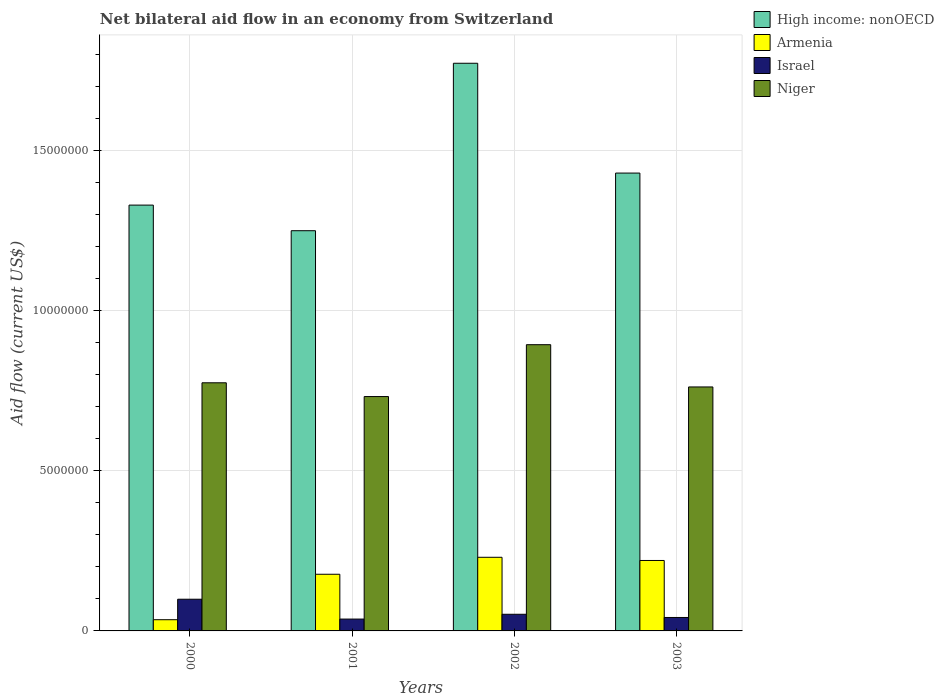How many groups of bars are there?
Offer a terse response. 4. Are the number of bars per tick equal to the number of legend labels?
Offer a terse response. Yes. Are the number of bars on each tick of the X-axis equal?
Give a very brief answer. Yes. What is the label of the 2nd group of bars from the left?
Give a very brief answer. 2001. In how many cases, is the number of bars for a given year not equal to the number of legend labels?
Offer a terse response. 0. What is the net bilateral aid flow in Armenia in 2002?
Give a very brief answer. 2.30e+06. Across all years, what is the maximum net bilateral aid flow in Armenia?
Provide a succinct answer. 2.30e+06. In which year was the net bilateral aid flow in Niger maximum?
Offer a terse response. 2002. What is the total net bilateral aid flow in Niger in the graph?
Your response must be concise. 3.16e+07. What is the difference between the net bilateral aid flow in High income: nonOECD in 2000 and that in 2002?
Make the answer very short. -4.43e+06. What is the difference between the net bilateral aid flow in Armenia in 2003 and the net bilateral aid flow in High income: nonOECD in 2001?
Your answer should be compact. -1.03e+07. What is the average net bilateral aid flow in Niger per year?
Ensure brevity in your answer.  7.91e+06. In the year 2002, what is the difference between the net bilateral aid flow in Israel and net bilateral aid flow in Niger?
Your answer should be very brief. -8.42e+06. What is the ratio of the net bilateral aid flow in Niger in 2001 to that in 2003?
Give a very brief answer. 0.96. What is the difference between the highest and the second highest net bilateral aid flow in High income: nonOECD?
Give a very brief answer. 3.43e+06. What is the difference between the highest and the lowest net bilateral aid flow in Niger?
Make the answer very short. 1.62e+06. In how many years, is the net bilateral aid flow in Israel greater than the average net bilateral aid flow in Israel taken over all years?
Your answer should be very brief. 1. Is the sum of the net bilateral aid flow in High income: nonOECD in 2001 and 2002 greater than the maximum net bilateral aid flow in Armenia across all years?
Your answer should be very brief. Yes. What does the 2nd bar from the left in 2001 represents?
Give a very brief answer. Armenia. What does the 4th bar from the right in 2002 represents?
Provide a succinct answer. High income: nonOECD. Is it the case that in every year, the sum of the net bilateral aid flow in Armenia and net bilateral aid flow in Israel is greater than the net bilateral aid flow in Niger?
Give a very brief answer. No. Are all the bars in the graph horizontal?
Offer a terse response. No. How many years are there in the graph?
Make the answer very short. 4. What is the difference between two consecutive major ticks on the Y-axis?
Your answer should be very brief. 5.00e+06. Does the graph contain grids?
Provide a succinct answer. Yes. How many legend labels are there?
Provide a short and direct response. 4. How are the legend labels stacked?
Ensure brevity in your answer.  Vertical. What is the title of the graph?
Your answer should be very brief. Net bilateral aid flow in an economy from Switzerland. Does "Kuwait" appear as one of the legend labels in the graph?
Offer a very short reply. No. What is the label or title of the X-axis?
Offer a very short reply. Years. What is the Aid flow (current US$) of High income: nonOECD in 2000?
Give a very brief answer. 1.33e+07. What is the Aid flow (current US$) of Armenia in 2000?
Provide a succinct answer. 3.50e+05. What is the Aid flow (current US$) in Israel in 2000?
Your answer should be compact. 9.90e+05. What is the Aid flow (current US$) in Niger in 2000?
Keep it short and to the point. 7.75e+06. What is the Aid flow (current US$) of High income: nonOECD in 2001?
Make the answer very short. 1.25e+07. What is the Aid flow (current US$) of Armenia in 2001?
Provide a succinct answer. 1.77e+06. What is the Aid flow (current US$) in Israel in 2001?
Provide a succinct answer. 3.70e+05. What is the Aid flow (current US$) in Niger in 2001?
Your answer should be compact. 7.32e+06. What is the Aid flow (current US$) in High income: nonOECD in 2002?
Your answer should be very brief. 1.77e+07. What is the Aid flow (current US$) of Armenia in 2002?
Offer a terse response. 2.30e+06. What is the Aid flow (current US$) of Israel in 2002?
Your response must be concise. 5.20e+05. What is the Aid flow (current US$) in Niger in 2002?
Offer a very short reply. 8.94e+06. What is the Aid flow (current US$) of High income: nonOECD in 2003?
Ensure brevity in your answer.  1.43e+07. What is the Aid flow (current US$) in Armenia in 2003?
Keep it short and to the point. 2.20e+06. What is the Aid flow (current US$) of Niger in 2003?
Offer a terse response. 7.62e+06. Across all years, what is the maximum Aid flow (current US$) of High income: nonOECD?
Make the answer very short. 1.77e+07. Across all years, what is the maximum Aid flow (current US$) of Armenia?
Your response must be concise. 2.30e+06. Across all years, what is the maximum Aid flow (current US$) of Israel?
Make the answer very short. 9.90e+05. Across all years, what is the maximum Aid flow (current US$) of Niger?
Provide a short and direct response. 8.94e+06. Across all years, what is the minimum Aid flow (current US$) of High income: nonOECD?
Your response must be concise. 1.25e+07. Across all years, what is the minimum Aid flow (current US$) of Armenia?
Your response must be concise. 3.50e+05. Across all years, what is the minimum Aid flow (current US$) in Israel?
Your answer should be very brief. 3.70e+05. Across all years, what is the minimum Aid flow (current US$) in Niger?
Your response must be concise. 7.32e+06. What is the total Aid flow (current US$) in High income: nonOECD in the graph?
Keep it short and to the point. 5.78e+07. What is the total Aid flow (current US$) of Armenia in the graph?
Give a very brief answer. 6.62e+06. What is the total Aid flow (current US$) in Israel in the graph?
Make the answer very short. 2.30e+06. What is the total Aid flow (current US$) of Niger in the graph?
Offer a very short reply. 3.16e+07. What is the difference between the Aid flow (current US$) in High income: nonOECD in 2000 and that in 2001?
Your answer should be compact. 8.00e+05. What is the difference between the Aid flow (current US$) of Armenia in 2000 and that in 2001?
Make the answer very short. -1.42e+06. What is the difference between the Aid flow (current US$) of Israel in 2000 and that in 2001?
Your answer should be very brief. 6.20e+05. What is the difference between the Aid flow (current US$) in High income: nonOECD in 2000 and that in 2002?
Provide a short and direct response. -4.43e+06. What is the difference between the Aid flow (current US$) of Armenia in 2000 and that in 2002?
Provide a short and direct response. -1.95e+06. What is the difference between the Aid flow (current US$) in Niger in 2000 and that in 2002?
Offer a very short reply. -1.19e+06. What is the difference between the Aid flow (current US$) in Armenia in 2000 and that in 2003?
Your response must be concise. -1.85e+06. What is the difference between the Aid flow (current US$) of Israel in 2000 and that in 2003?
Ensure brevity in your answer.  5.70e+05. What is the difference between the Aid flow (current US$) of High income: nonOECD in 2001 and that in 2002?
Your answer should be compact. -5.23e+06. What is the difference between the Aid flow (current US$) in Armenia in 2001 and that in 2002?
Provide a succinct answer. -5.30e+05. What is the difference between the Aid flow (current US$) of Niger in 2001 and that in 2002?
Give a very brief answer. -1.62e+06. What is the difference between the Aid flow (current US$) of High income: nonOECD in 2001 and that in 2003?
Ensure brevity in your answer.  -1.80e+06. What is the difference between the Aid flow (current US$) in Armenia in 2001 and that in 2003?
Keep it short and to the point. -4.30e+05. What is the difference between the Aid flow (current US$) in High income: nonOECD in 2002 and that in 2003?
Ensure brevity in your answer.  3.43e+06. What is the difference between the Aid flow (current US$) of Armenia in 2002 and that in 2003?
Offer a terse response. 1.00e+05. What is the difference between the Aid flow (current US$) in Israel in 2002 and that in 2003?
Offer a terse response. 1.00e+05. What is the difference between the Aid flow (current US$) in Niger in 2002 and that in 2003?
Make the answer very short. 1.32e+06. What is the difference between the Aid flow (current US$) in High income: nonOECD in 2000 and the Aid flow (current US$) in Armenia in 2001?
Offer a very short reply. 1.15e+07. What is the difference between the Aid flow (current US$) of High income: nonOECD in 2000 and the Aid flow (current US$) of Israel in 2001?
Provide a short and direct response. 1.29e+07. What is the difference between the Aid flow (current US$) in High income: nonOECD in 2000 and the Aid flow (current US$) in Niger in 2001?
Offer a terse response. 5.98e+06. What is the difference between the Aid flow (current US$) of Armenia in 2000 and the Aid flow (current US$) of Israel in 2001?
Provide a short and direct response. -2.00e+04. What is the difference between the Aid flow (current US$) of Armenia in 2000 and the Aid flow (current US$) of Niger in 2001?
Make the answer very short. -6.97e+06. What is the difference between the Aid flow (current US$) in Israel in 2000 and the Aid flow (current US$) in Niger in 2001?
Give a very brief answer. -6.33e+06. What is the difference between the Aid flow (current US$) in High income: nonOECD in 2000 and the Aid flow (current US$) in Armenia in 2002?
Ensure brevity in your answer.  1.10e+07. What is the difference between the Aid flow (current US$) in High income: nonOECD in 2000 and the Aid flow (current US$) in Israel in 2002?
Your answer should be compact. 1.28e+07. What is the difference between the Aid flow (current US$) of High income: nonOECD in 2000 and the Aid flow (current US$) of Niger in 2002?
Ensure brevity in your answer.  4.36e+06. What is the difference between the Aid flow (current US$) of Armenia in 2000 and the Aid flow (current US$) of Israel in 2002?
Offer a terse response. -1.70e+05. What is the difference between the Aid flow (current US$) in Armenia in 2000 and the Aid flow (current US$) in Niger in 2002?
Keep it short and to the point. -8.59e+06. What is the difference between the Aid flow (current US$) of Israel in 2000 and the Aid flow (current US$) of Niger in 2002?
Keep it short and to the point. -7.95e+06. What is the difference between the Aid flow (current US$) in High income: nonOECD in 2000 and the Aid flow (current US$) in Armenia in 2003?
Offer a terse response. 1.11e+07. What is the difference between the Aid flow (current US$) of High income: nonOECD in 2000 and the Aid flow (current US$) of Israel in 2003?
Offer a very short reply. 1.29e+07. What is the difference between the Aid flow (current US$) in High income: nonOECD in 2000 and the Aid flow (current US$) in Niger in 2003?
Your answer should be very brief. 5.68e+06. What is the difference between the Aid flow (current US$) of Armenia in 2000 and the Aid flow (current US$) of Niger in 2003?
Provide a succinct answer. -7.27e+06. What is the difference between the Aid flow (current US$) of Israel in 2000 and the Aid flow (current US$) of Niger in 2003?
Provide a short and direct response. -6.63e+06. What is the difference between the Aid flow (current US$) in High income: nonOECD in 2001 and the Aid flow (current US$) in Armenia in 2002?
Offer a terse response. 1.02e+07. What is the difference between the Aid flow (current US$) in High income: nonOECD in 2001 and the Aid flow (current US$) in Israel in 2002?
Your answer should be compact. 1.20e+07. What is the difference between the Aid flow (current US$) of High income: nonOECD in 2001 and the Aid flow (current US$) of Niger in 2002?
Your answer should be very brief. 3.56e+06. What is the difference between the Aid flow (current US$) of Armenia in 2001 and the Aid flow (current US$) of Israel in 2002?
Make the answer very short. 1.25e+06. What is the difference between the Aid flow (current US$) of Armenia in 2001 and the Aid flow (current US$) of Niger in 2002?
Provide a succinct answer. -7.17e+06. What is the difference between the Aid flow (current US$) of Israel in 2001 and the Aid flow (current US$) of Niger in 2002?
Provide a succinct answer. -8.57e+06. What is the difference between the Aid flow (current US$) of High income: nonOECD in 2001 and the Aid flow (current US$) of Armenia in 2003?
Ensure brevity in your answer.  1.03e+07. What is the difference between the Aid flow (current US$) in High income: nonOECD in 2001 and the Aid flow (current US$) in Israel in 2003?
Ensure brevity in your answer.  1.21e+07. What is the difference between the Aid flow (current US$) of High income: nonOECD in 2001 and the Aid flow (current US$) of Niger in 2003?
Provide a succinct answer. 4.88e+06. What is the difference between the Aid flow (current US$) in Armenia in 2001 and the Aid flow (current US$) in Israel in 2003?
Make the answer very short. 1.35e+06. What is the difference between the Aid flow (current US$) of Armenia in 2001 and the Aid flow (current US$) of Niger in 2003?
Ensure brevity in your answer.  -5.85e+06. What is the difference between the Aid flow (current US$) in Israel in 2001 and the Aid flow (current US$) in Niger in 2003?
Make the answer very short. -7.25e+06. What is the difference between the Aid flow (current US$) of High income: nonOECD in 2002 and the Aid flow (current US$) of Armenia in 2003?
Offer a terse response. 1.55e+07. What is the difference between the Aid flow (current US$) in High income: nonOECD in 2002 and the Aid flow (current US$) in Israel in 2003?
Offer a very short reply. 1.73e+07. What is the difference between the Aid flow (current US$) of High income: nonOECD in 2002 and the Aid flow (current US$) of Niger in 2003?
Provide a succinct answer. 1.01e+07. What is the difference between the Aid flow (current US$) in Armenia in 2002 and the Aid flow (current US$) in Israel in 2003?
Provide a short and direct response. 1.88e+06. What is the difference between the Aid flow (current US$) in Armenia in 2002 and the Aid flow (current US$) in Niger in 2003?
Keep it short and to the point. -5.32e+06. What is the difference between the Aid flow (current US$) in Israel in 2002 and the Aid flow (current US$) in Niger in 2003?
Make the answer very short. -7.10e+06. What is the average Aid flow (current US$) of High income: nonOECD per year?
Your answer should be very brief. 1.45e+07. What is the average Aid flow (current US$) of Armenia per year?
Give a very brief answer. 1.66e+06. What is the average Aid flow (current US$) of Israel per year?
Your response must be concise. 5.75e+05. What is the average Aid flow (current US$) of Niger per year?
Make the answer very short. 7.91e+06. In the year 2000, what is the difference between the Aid flow (current US$) of High income: nonOECD and Aid flow (current US$) of Armenia?
Offer a terse response. 1.30e+07. In the year 2000, what is the difference between the Aid flow (current US$) of High income: nonOECD and Aid flow (current US$) of Israel?
Your answer should be compact. 1.23e+07. In the year 2000, what is the difference between the Aid flow (current US$) in High income: nonOECD and Aid flow (current US$) in Niger?
Offer a very short reply. 5.55e+06. In the year 2000, what is the difference between the Aid flow (current US$) of Armenia and Aid flow (current US$) of Israel?
Give a very brief answer. -6.40e+05. In the year 2000, what is the difference between the Aid flow (current US$) of Armenia and Aid flow (current US$) of Niger?
Ensure brevity in your answer.  -7.40e+06. In the year 2000, what is the difference between the Aid flow (current US$) in Israel and Aid flow (current US$) in Niger?
Provide a short and direct response. -6.76e+06. In the year 2001, what is the difference between the Aid flow (current US$) in High income: nonOECD and Aid flow (current US$) in Armenia?
Your answer should be compact. 1.07e+07. In the year 2001, what is the difference between the Aid flow (current US$) in High income: nonOECD and Aid flow (current US$) in Israel?
Offer a very short reply. 1.21e+07. In the year 2001, what is the difference between the Aid flow (current US$) of High income: nonOECD and Aid flow (current US$) of Niger?
Keep it short and to the point. 5.18e+06. In the year 2001, what is the difference between the Aid flow (current US$) of Armenia and Aid flow (current US$) of Israel?
Your answer should be very brief. 1.40e+06. In the year 2001, what is the difference between the Aid flow (current US$) of Armenia and Aid flow (current US$) of Niger?
Your response must be concise. -5.55e+06. In the year 2001, what is the difference between the Aid flow (current US$) in Israel and Aid flow (current US$) in Niger?
Make the answer very short. -6.95e+06. In the year 2002, what is the difference between the Aid flow (current US$) of High income: nonOECD and Aid flow (current US$) of Armenia?
Your answer should be very brief. 1.54e+07. In the year 2002, what is the difference between the Aid flow (current US$) in High income: nonOECD and Aid flow (current US$) in Israel?
Provide a succinct answer. 1.72e+07. In the year 2002, what is the difference between the Aid flow (current US$) of High income: nonOECD and Aid flow (current US$) of Niger?
Your answer should be very brief. 8.79e+06. In the year 2002, what is the difference between the Aid flow (current US$) of Armenia and Aid flow (current US$) of Israel?
Your response must be concise. 1.78e+06. In the year 2002, what is the difference between the Aid flow (current US$) of Armenia and Aid flow (current US$) of Niger?
Provide a succinct answer. -6.64e+06. In the year 2002, what is the difference between the Aid flow (current US$) of Israel and Aid flow (current US$) of Niger?
Offer a very short reply. -8.42e+06. In the year 2003, what is the difference between the Aid flow (current US$) of High income: nonOECD and Aid flow (current US$) of Armenia?
Offer a very short reply. 1.21e+07. In the year 2003, what is the difference between the Aid flow (current US$) in High income: nonOECD and Aid flow (current US$) in Israel?
Provide a short and direct response. 1.39e+07. In the year 2003, what is the difference between the Aid flow (current US$) of High income: nonOECD and Aid flow (current US$) of Niger?
Offer a very short reply. 6.68e+06. In the year 2003, what is the difference between the Aid flow (current US$) of Armenia and Aid flow (current US$) of Israel?
Provide a short and direct response. 1.78e+06. In the year 2003, what is the difference between the Aid flow (current US$) of Armenia and Aid flow (current US$) of Niger?
Offer a very short reply. -5.42e+06. In the year 2003, what is the difference between the Aid flow (current US$) in Israel and Aid flow (current US$) in Niger?
Provide a short and direct response. -7.20e+06. What is the ratio of the Aid flow (current US$) in High income: nonOECD in 2000 to that in 2001?
Provide a short and direct response. 1.06. What is the ratio of the Aid flow (current US$) in Armenia in 2000 to that in 2001?
Provide a short and direct response. 0.2. What is the ratio of the Aid flow (current US$) of Israel in 2000 to that in 2001?
Your response must be concise. 2.68. What is the ratio of the Aid flow (current US$) of Niger in 2000 to that in 2001?
Offer a terse response. 1.06. What is the ratio of the Aid flow (current US$) of High income: nonOECD in 2000 to that in 2002?
Ensure brevity in your answer.  0.75. What is the ratio of the Aid flow (current US$) in Armenia in 2000 to that in 2002?
Give a very brief answer. 0.15. What is the ratio of the Aid flow (current US$) in Israel in 2000 to that in 2002?
Your response must be concise. 1.9. What is the ratio of the Aid flow (current US$) in Niger in 2000 to that in 2002?
Keep it short and to the point. 0.87. What is the ratio of the Aid flow (current US$) in High income: nonOECD in 2000 to that in 2003?
Provide a succinct answer. 0.93. What is the ratio of the Aid flow (current US$) of Armenia in 2000 to that in 2003?
Offer a terse response. 0.16. What is the ratio of the Aid flow (current US$) in Israel in 2000 to that in 2003?
Offer a very short reply. 2.36. What is the ratio of the Aid flow (current US$) of Niger in 2000 to that in 2003?
Make the answer very short. 1.02. What is the ratio of the Aid flow (current US$) in High income: nonOECD in 2001 to that in 2002?
Your response must be concise. 0.7. What is the ratio of the Aid flow (current US$) in Armenia in 2001 to that in 2002?
Your answer should be compact. 0.77. What is the ratio of the Aid flow (current US$) in Israel in 2001 to that in 2002?
Your response must be concise. 0.71. What is the ratio of the Aid flow (current US$) in Niger in 2001 to that in 2002?
Keep it short and to the point. 0.82. What is the ratio of the Aid flow (current US$) of High income: nonOECD in 2001 to that in 2003?
Keep it short and to the point. 0.87. What is the ratio of the Aid flow (current US$) in Armenia in 2001 to that in 2003?
Offer a very short reply. 0.8. What is the ratio of the Aid flow (current US$) in Israel in 2001 to that in 2003?
Your answer should be compact. 0.88. What is the ratio of the Aid flow (current US$) in Niger in 2001 to that in 2003?
Offer a very short reply. 0.96. What is the ratio of the Aid flow (current US$) of High income: nonOECD in 2002 to that in 2003?
Offer a terse response. 1.24. What is the ratio of the Aid flow (current US$) in Armenia in 2002 to that in 2003?
Your answer should be very brief. 1.05. What is the ratio of the Aid flow (current US$) in Israel in 2002 to that in 2003?
Your answer should be compact. 1.24. What is the ratio of the Aid flow (current US$) in Niger in 2002 to that in 2003?
Your answer should be very brief. 1.17. What is the difference between the highest and the second highest Aid flow (current US$) of High income: nonOECD?
Ensure brevity in your answer.  3.43e+06. What is the difference between the highest and the second highest Aid flow (current US$) in Armenia?
Your answer should be very brief. 1.00e+05. What is the difference between the highest and the second highest Aid flow (current US$) in Israel?
Provide a succinct answer. 4.70e+05. What is the difference between the highest and the second highest Aid flow (current US$) of Niger?
Provide a short and direct response. 1.19e+06. What is the difference between the highest and the lowest Aid flow (current US$) of High income: nonOECD?
Offer a terse response. 5.23e+06. What is the difference between the highest and the lowest Aid flow (current US$) of Armenia?
Offer a terse response. 1.95e+06. What is the difference between the highest and the lowest Aid flow (current US$) of Israel?
Provide a short and direct response. 6.20e+05. What is the difference between the highest and the lowest Aid flow (current US$) in Niger?
Your answer should be very brief. 1.62e+06. 